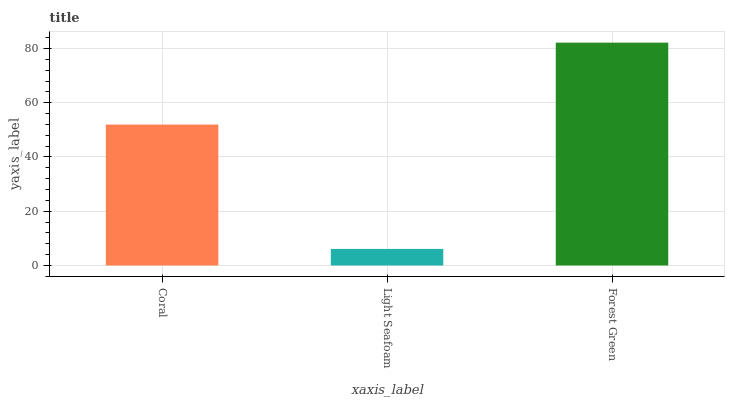Is Light Seafoam the minimum?
Answer yes or no. Yes. Is Forest Green the maximum?
Answer yes or no. Yes. Is Forest Green the minimum?
Answer yes or no. No. Is Light Seafoam the maximum?
Answer yes or no. No. Is Forest Green greater than Light Seafoam?
Answer yes or no. Yes. Is Light Seafoam less than Forest Green?
Answer yes or no. Yes. Is Light Seafoam greater than Forest Green?
Answer yes or no. No. Is Forest Green less than Light Seafoam?
Answer yes or no. No. Is Coral the high median?
Answer yes or no. Yes. Is Coral the low median?
Answer yes or no. Yes. Is Light Seafoam the high median?
Answer yes or no. No. Is Light Seafoam the low median?
Answer yes or no. No. 